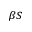<formula> <loc_0><loc_0><loc_500><loc_500>_ { \beta S }</formula> 